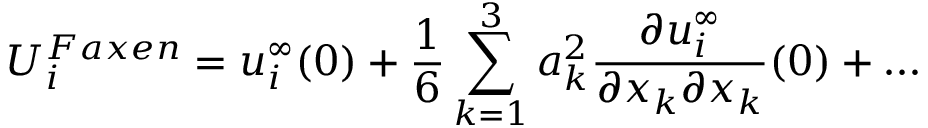<formula> <loc_0><loc_0><loc_500><loc_500>U _ { i } ^ { F a x e n } = u _ { i } ^ { \infty } ( 0 ) + \frac { 1 } { 6 } \sum _ { k = 1 } ^ { 3 } a _ { k } ^ { 2 } \frac { \partial u _ { i } ^ { \infty } } { \partial x _ { k } \partial x _ { k } } ( 0 ) + \dots</formula> 